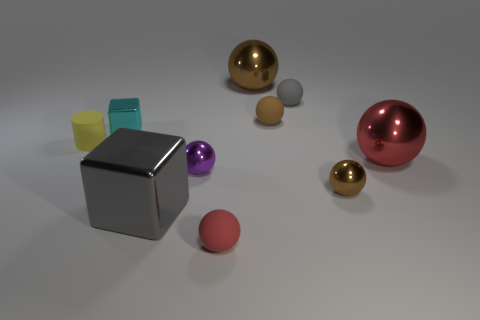Subtract all red cylinders. How many brown spheres are left? 3 Subtract 4 balls. How many balls are left? 3 Subtract all gray balls. How many balls are left? 6 Subtract all red spheres. How many spheres are left? 5 Subtract all blue spheres. Subtract all blue cylinders. How many spheres are left? 7 Subtract all blocks. How many objects are left? 8 Add 7 big yellow spheres. How many big yellow spheres exist? 7 Subtract 0 green blocks. How many objects are left? 10 Subtract all tiny green matte cubes. Subtract all tiny yellow things. How many objects are left? 9 Add 3 purple metallic balls. How many purple metallic balls are left? 4 